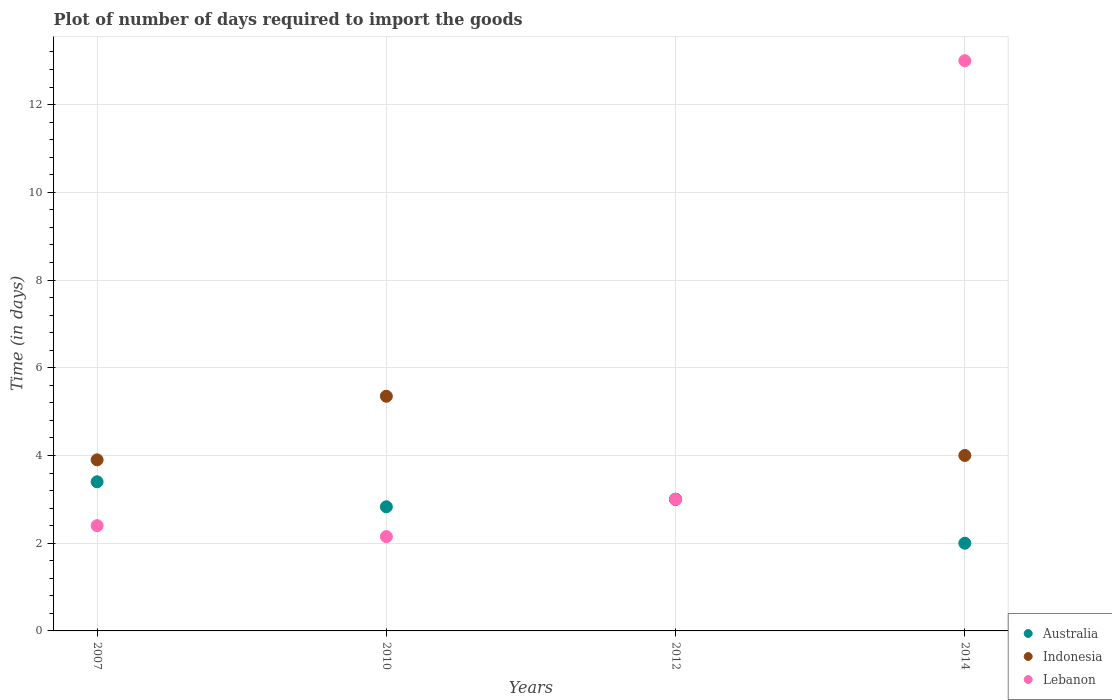How many different coloured dotlines are there?
Offer a very short reply. 3. Across all years, what is the maximum time required to import goods in Indonesia?
Provide a succinct answer. 5.35. In which year was the time required to import goods in Lebanon maximum?
Give a very brief answer. 2014. What is the total time required to import goods in Australia in the graph?
Provide a succinct answer. 11.23. What is the difference between the time required to import goods in Australia in 2007 and that in 2014?
Your answer should be compact. 1.4. What is the difference between the time required to import goods in Indonesia in 2007 and the time required to import goods in Australia in 2012?
Your response must be concise. 0.9. What is the average time required to import goods in Lebanon per year?
Your response must be concise. 5.14. In the year 2007, what is the difference between the time required to import goods in Lebanon and time required to import goods in Australia?
Your answer should be very brief. -1. What is the ratio of the time required to import goods in Lebanon in 2007 to that in 2012?
Your answer should be compact. 0.8. What is the difference between the highest and the second highest time required to import goods in Lebanon?
Your response must be concise. 10. Is the sum of the time required to import goods in Indonesia in 2007 and 2010 greater than the maximum time required to import goods in Lebanon across all years?
Give a very brief answer. No. Does the time required to import goods in Lebanon monotonically increase over the years?
Offer a very short reply. No. Is the time required to import goods in Lebanon strictly greater than the time required to import goods in Indonesia over the years?
Ensure brevity in your answer.  No. Is the time required to import goods in Indonesia strictly less than the time required to import goods in Australia over the years?
Offer a terse response. No. How many years are there in the graph?
Make the answer very short. 4. What is the difference between two consecutive major ticks on the Y-axis?
Ensure brevity in your answer.  2. Does the graph contain any zero values?
Keep it short and to the point. No. Does the graph contain grids?
Your response must be concise. Yes. How are the legend labels stacked?
Keep it short and to the point. Vertical. What is the title of the graph?
Provide a short and direct response. Plot of number of days required to import the goods. What is the label or title of the Y-axis?
Your response must be concise. Time (in days). What is the Time (in days) of Lebanon in 2007?
Your answer should be very brief. 2.4. What is the Time (in days) of Australia in 2010?
Keep it short and to the point. 2.83. What is the Time (in days) in Indonesia in 2010?
Provide a short and direct response. 5.35. What is the Time (in days) of Lebanon in 2010?
Ensure brevity in your answer.  2.15. What is the Time (in days) in Australia in 2014?
Offer a terse response. 2. What is the Time (in days) of Indonesia in 2014?
Offer a terse response. 4. Across all years, what is the maximum Time (in days) in Australia?
Your answer should be very brief. 3.4. Across all years, what is the maximum Time (in days) in Indonesia?
Your response must be concise. 5.35. Across all years, what is the maximum Time (in days) in Lebanon?
Offer a very short reply. 13. Across all years, what is the minimum Time (in days) in Australia?
Your response must be concise. 2. Across all years, what is the minimum Time (in days) of Indonesia?
Provide a short and direct response. 3. Across all years, what is the minimum Time (in days) in Lebanon?
Your answer should be compact. 2.15. What is the total Time (in days) in Australia in the graph?
Ensure brevity in your answer.  11.23. What is the total Time (in days) in Indonesia in the graph?
Your answer should be very brief. 16.25. What is the total Time (in days) of Lebanon in the graph?
Your response must be concise. 20.55. What is the difference between the Time (in days) of Australia in 2007 and that in 2010?
Ensure brevity in your answer.  0.57. What is the difference between the Time (in days) of Indonesia in 2007 and that in 2010?
Your answer should be very brief. -1.45. What is the difference between the Time (in days) of Indonesia in 2007 and that in 2012?
Your answer should be very brief. 0.9. What is the difference between the Time (in days) in Australia in 2007 and that in 2014?
Provide a succinct answer. 1.4. What is the difference between the Time (in days) of Lebanon in 2007 and that in 2014?
Offer a terse response. -10.6. What is the difference between the Time (in days) in Australia in 2010 and that in 2012?
Offer a terse response. -0.17. What is the difference between the Time (in days) in Indonesia in 2010 and that in 2012?
Provide a succinct answer. 2.35. What is the difference between the Time (in days) in Lebanon in 2010 and that in 2012?
Provide a short and direct response. -0.85. What is the difference between the Time (in days) in Australia in 2010 and that in 2014?
Your response must be concise. 0.83. What is the difference between the Time (in days) of Indonesia in 2010 and that in 2014?
Keep it short and to the point. 1.35. What is the difference between the Time (in days) of Lebanon in 2010 and that in 2014?
Ensure brevity in your answer.  -10.85. What is the difference between the Time (in days) of Australia in 2012 and that in 2014?
Provide a succinct answer. 1. What is the difference between the Time (in days) of Lebanon in 2012 and that in 2014?
Your answer should be very brief. -10. What is the difference between the Time (in days) of Australia in 2007 and the Time (in days) of Indonesia in 2010?
Ensure brevity in your answer.  -1.95. What is the difference between the Time (in days) in Australia in 2007 and the Time (in days) in Lebanon in 2010?
Keep it short and to the point. 1.25. What is the difference between the Time (in days) of Indonesia in 2007 and the Time (in days) of Lebanon in 2010?
Ensure brevity in your answer.  1.75. What is the difference between the Time (in days) of Australia in 2007 and the Time (in days) of Lebanon in 2012?
Ensure brevity in your answer.  0.4. What is the difference between the Time (in days) of Indonesia in 2007 and the Time (in days) of Lebanon in 2012?
Offer a very short reply. 0.9. What is the difference between the Time (in days) of Australia in 2007 and the Time (in days) of Indonesia in 2014?
Keep it short and to the point. -0.6. What is the difference between the Time (in days) in Australia in 2007 and the Time (in days) in Lebanon in 2014?
Offer a very short reply. -9.6. What is the difference between the Time (in days) of Indonesia in 2007 and the Time (in days) of Lebanon in 2014?
Your response must be concise. -9.1. What is the difference between the Time (in days) in Australia in 2010 and the Time (in days) in Indonesia in 2012?
Offer a very short reply. -0.17. What is the difference between the Time (in days) of Australia in 2010 and the Time (in days) of Lebanon in 2012?
Provide a short and direct response. -0.17. What is the difference between the Time (in days) of Indonesia in 2010 and the Time (in days) of Lebanon in 2012?
Keep it short and to the point. 2.35. What is the difference between the Time (in days) in Australia in 2010 and the Time (in days) in Indonesia in 2014?
Ensure brevity in your answer.  -1.17. What is the difference between the Time (in days) in Australia in 2010 and the Time (in days) in Lebanon in 2014?
Make the answer very short. -10.17. What is the difference between the Time (in days) of Indonesia in 2010 and the Time (in days) of Lebanon in 2014?
Provide a short and direct response. -7.65. What is the average Time (in days) of Australia per year?
Offer a very short reply. 2.81. What is the average Time (in days) in Indonesia per year?
Keep it short and to the point. 4.06. What is the average Time (in days) of Lebanon per year?
Provide a short and direct response. 5.14. In the year 2007, what is the difference between the Time (in days) in Australia and Time (in days) in Lebanon?
Offer a very short reply. 1. In the year 2010, what is the difference between the Time (in days) in Australia and Time (in days) in Indonesia?
Your answer should be compact. -2.52. In the year 2010, what is the difference between the Time (in days) in Australia and Time (in days) in Lebanon?
Provide a succinct answer. 0.68. In the year 2010, what is the difference between the Time (in days) in Indonesia and Time (in days) in Lebanon?
Keep it short and to the point. 3.2. In the year 2012, what is the difference between the Time (in days) of Australia and Time (in days) of Lebanon?
Make the answer very short. 0. In the year 2012, what is the difference between the Time (in days) of Indonesia and Time (in days) of Lebanon?
Your answer should be very brief. 0. In the year 2014, what is the difference between the Time (in days) of Australia and Time (in days) of Lebanon?
Provide a succinct answer. -11. In the year 2014, what is the difference between the Time (in days) in Indonesia and Time (in days) in Lebanon?
Your answer should be compact. -9. What is the ratio of the Time (in days) of Australia in 2007 to that in 2010?
Keep it short and to the point. 1.2. What is the ratio of the Time (in days) in Indonesia in 2007 to that in 2010?
Give a very brief answer. 0.73. What is the ratio of the Time (in days) of Lebanon in 2007 to that in 2010?
Offer a very short reply. 1.12. What is the ratio of the Time (in days) of Australia in 2007 to that in 2012?
Keep it short and to the point. 1.13. What is the ratio of the Time (in days) in Lebanon in 2007 to that in 2012?
Offer a very short reply. 0.8. What is the ratio of the Time (in days) in Indonesia in 2007 to that in 2014?
Keep it short and to the point. 0.97. What is the ratio of the Time (in days) of Lebanon in 2007 to that in 2014?
Give a very brief answer. 0.18. What is the ratio of the Time (in days) in Australia in 2010 to that in 2012?
Your answer should be compact. 0.94. What is the ratio of the Time (in days) in Indonesia in 2010 to that in 2012?
Your answer should be compact. 1.78. What is the ratio of the Time (in days) in Lebanon in 2010 to that in 2012?
Your answer should be compact. 0.72. What is the ratio of the Time (in days) of Australia in 2010 to that in 2014?
Keep it short and to the point. 1.42. What is the ratio of the Time (in days) in Indonesia in 2010 to that in 2014?
Offer a very short reply. 1.34. What is the ratio of the Time (in days) of Lebanon in 2010 to that in 2014?
Give a very brief answer. 0.17. What is the ratio of the Time (in days) of Australia in 2012 to that in 2014?
Your response must be concise. 1.5. What is the ratio of the Time (in days) of Lebanon in 2012 to that in 2014?
Your answer should be compact. 0.23. What is the difference between the highest and the second highest Time (in days) in Indonesia?
Your response must be concise. 1.35. What is the difference between the highest and the lowest Time (in days) in Indonesia?
Offer a very short reply. 2.35. What is the difference between the highest and the lowest Time (in days) in Lebanon?
Your answer should be very brief. 10.85. 